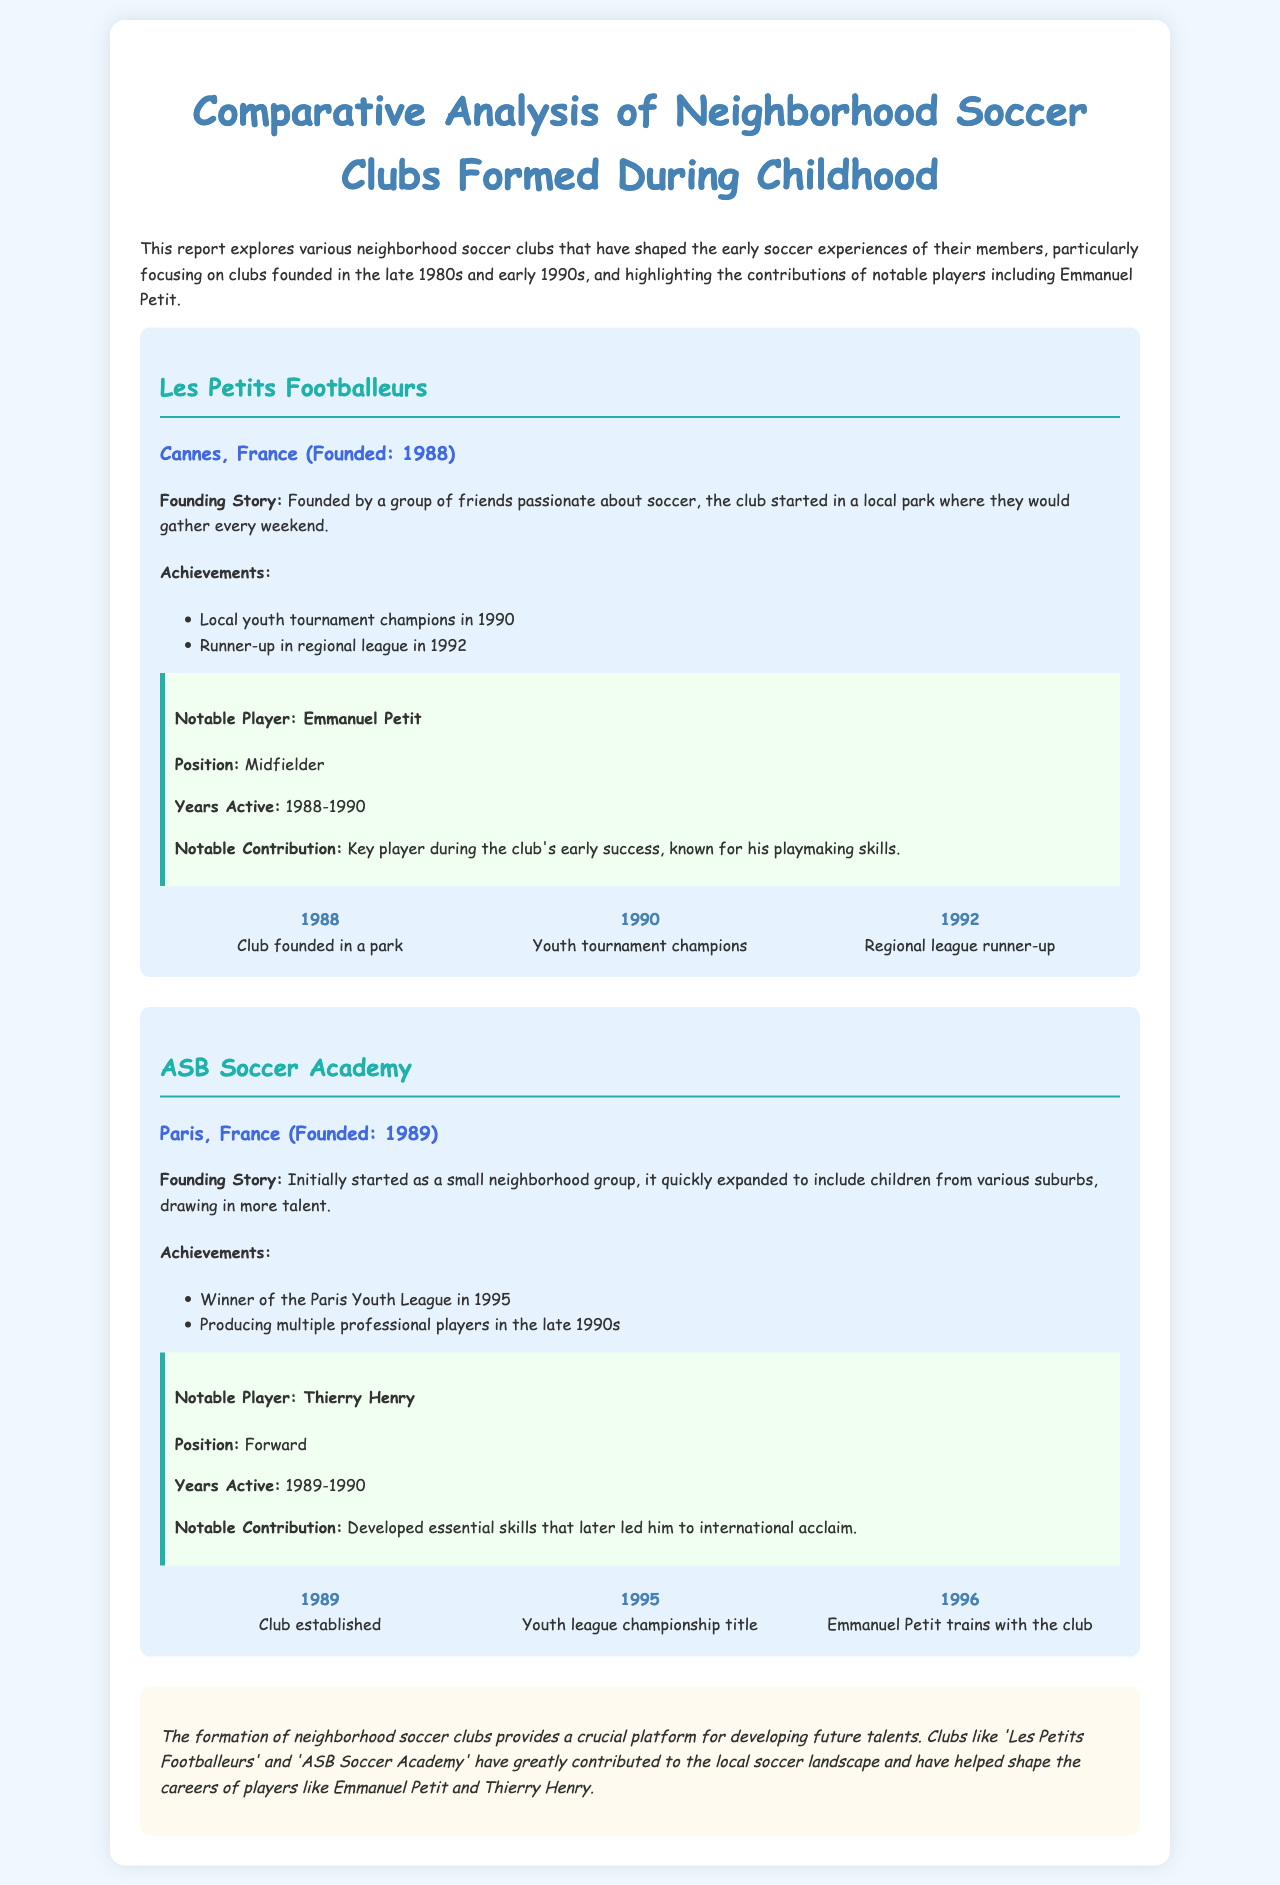What year was Les Petits Footballeurs founded? The document states that Les Petits Footballeurs was founded in Cannes, France in 1988.
Answer: 1988 Who was a notable player from Les Petits Footballeurs? The report lists Emmanuel Petit as a notable player for Les Petits Footballeurs.
Answer: Emmanuel Petit What was the achievement of ASB Soccer Academy in 1995? According to the document, ASB Soccer Academy won the Paris Youth League in 1995.
Answer: Winner of the Paris Youth League How many times did Les Petits Footballeurs win local youth tournaments? The document mentions that Les Petits Footballeurs won the local youth tournament champions in 1990.
Answer: Once What position did Thierry Henry play? The report indicates that Thierry Henry played as a Forward.
Answer: Forward Which club did Emmanuel Petit train with in 1996? The timeline in the document shows that Emmanuel Petit trained with ASB Soccer Academy in 1996.
Answer: ASB Soccer Academy What was the founding story of ASB Soccer Academy? The document outlines that it started as a small neighborhood group that quickly expanded to include children from various suburbs.
Answer: Small neighborhood group How many notable players are mentioned in the document? The report features two notable players: Emmanuel Petit and Thierry Henry.
Answer: Two 